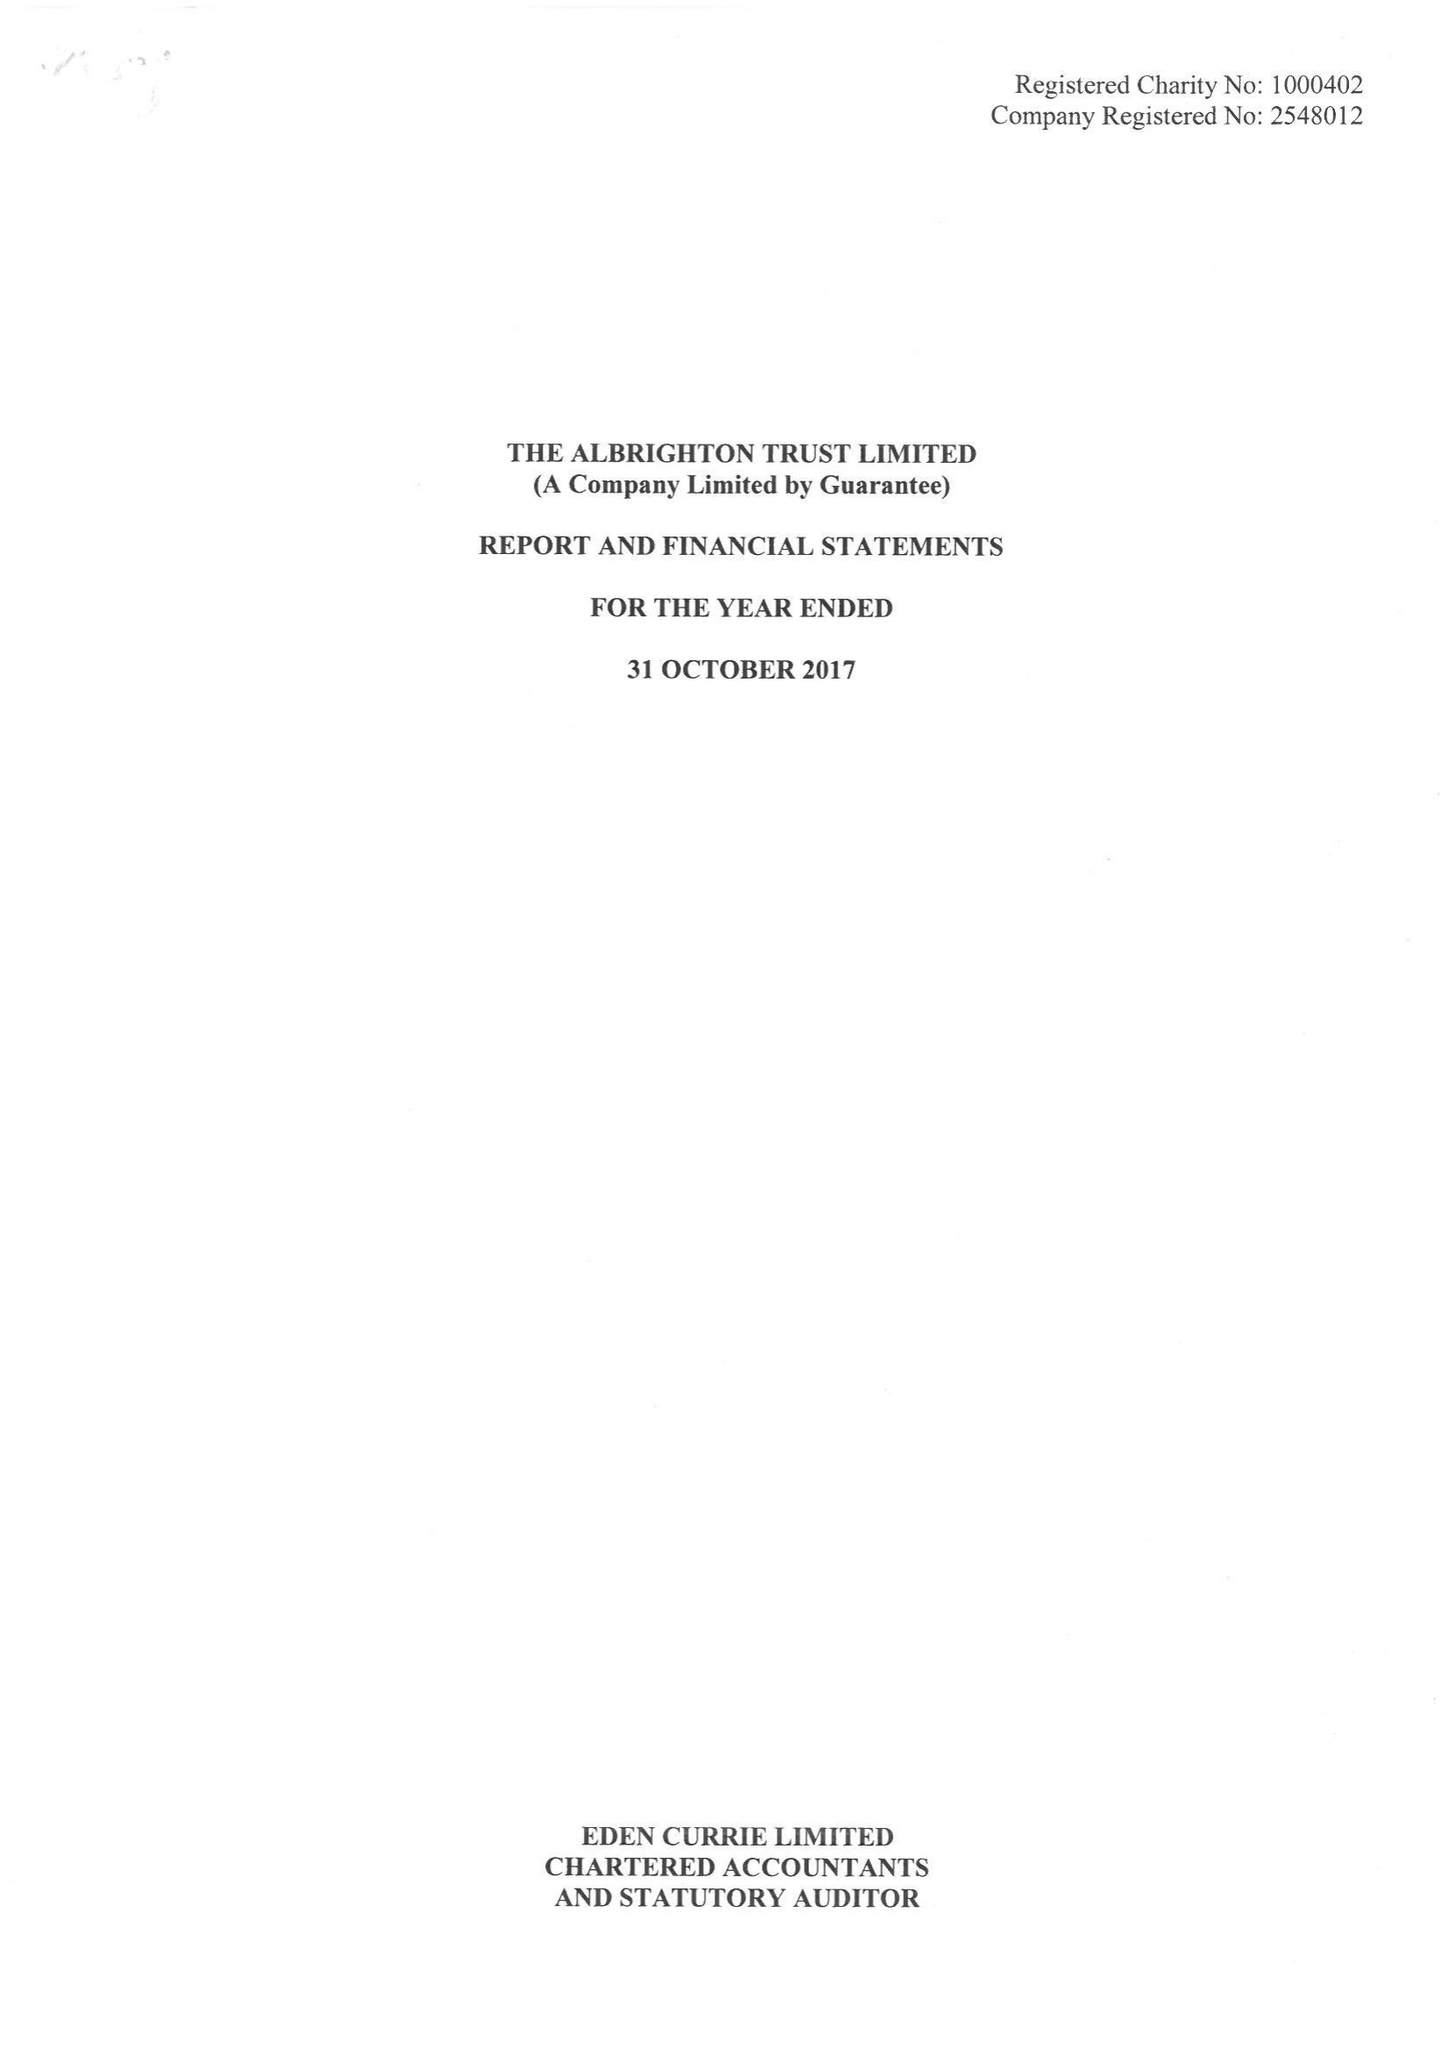What is the value for the report_date?
Answer the question using a single word or phrase. 2017-10-31 